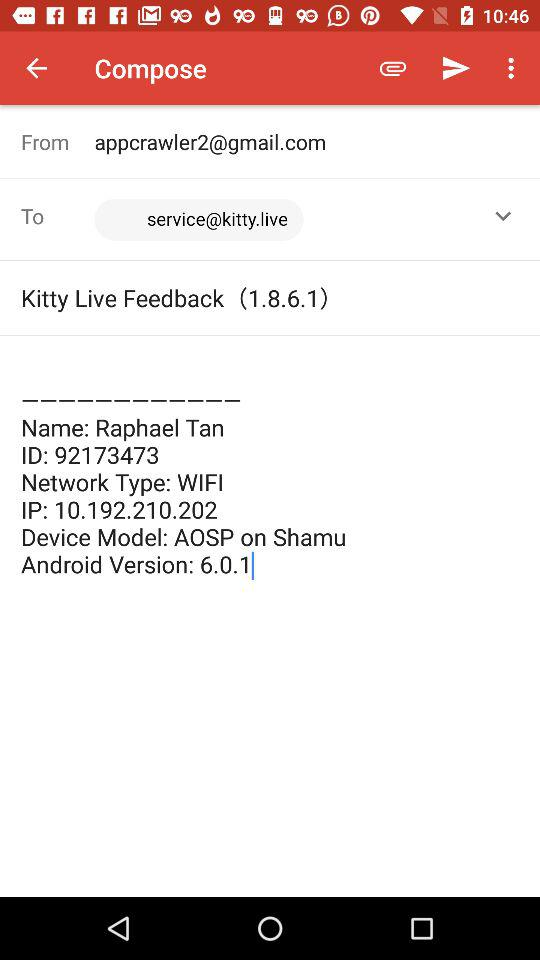What is the email address of the sender? The email address of the sender is appcrawler2@gmail.com. 